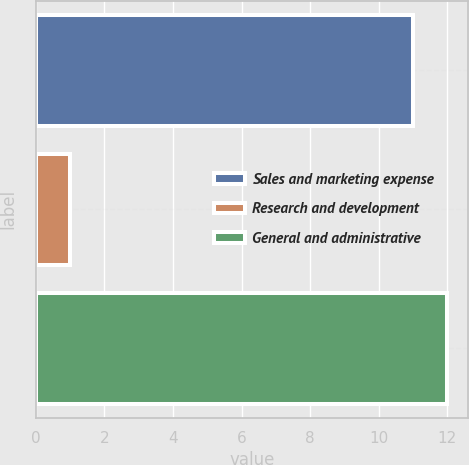Convert chart. <chart><loc_0><loc_0><loc_500><loc_500><bar_chart><fcel>Sales and marketing expense<fcel>Research and development<fcel>General and administrative<nl><fcel>11<fcel>1<fcel>12<nl></chart> 